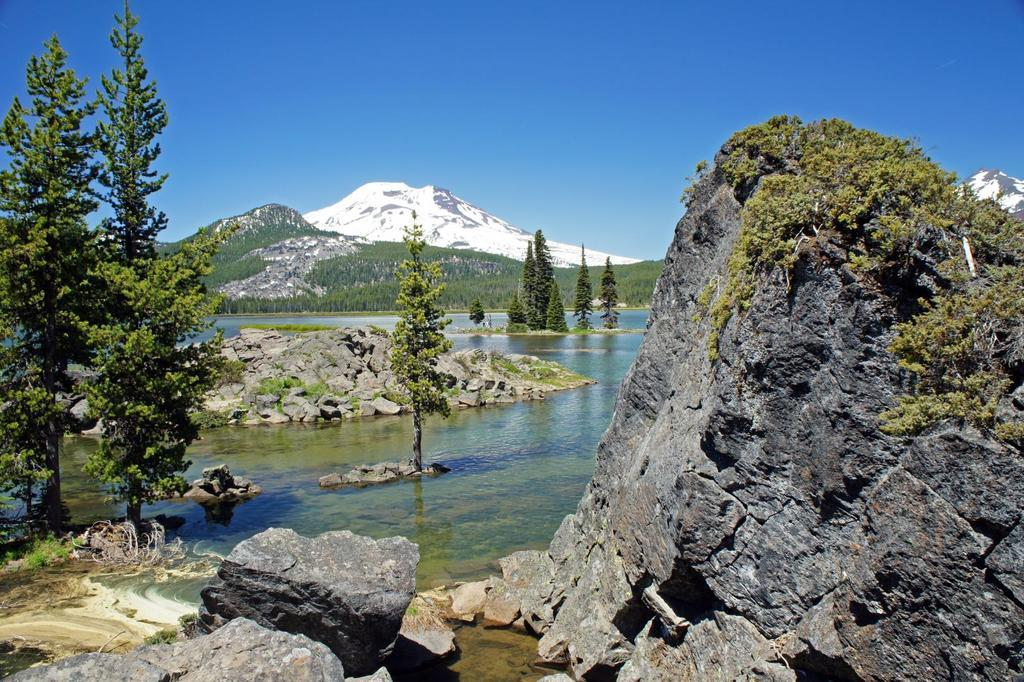What type of natural elements can be seen in the image? There are stones, water, trees, and mountains visible in the image. What is the condition of the sky in the background of the image? The sky is clear in the background of the image. How many chairs can be seen in the image? There are no chairs present in the image. What type of feather is floating in the water in the image? There is no feather present in the image. 